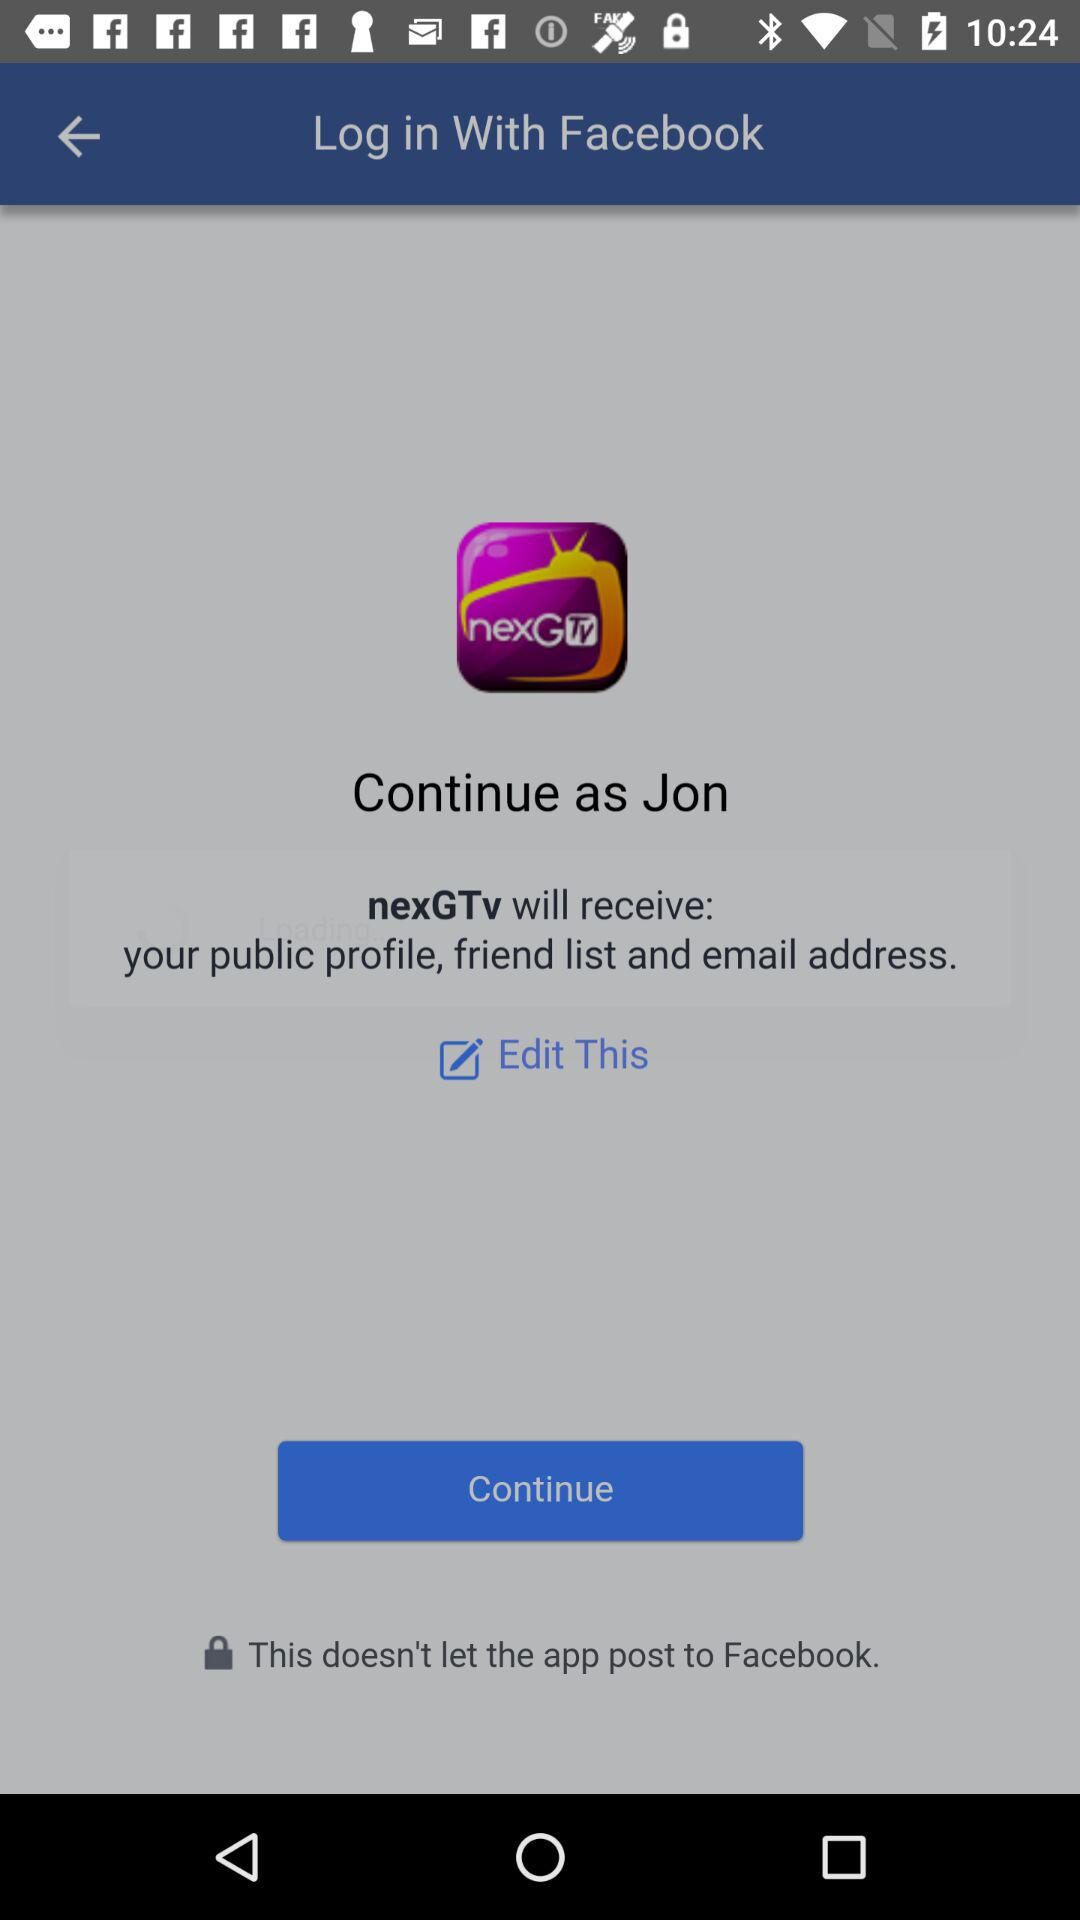What is the name of the user? The name of the user is Jon. 